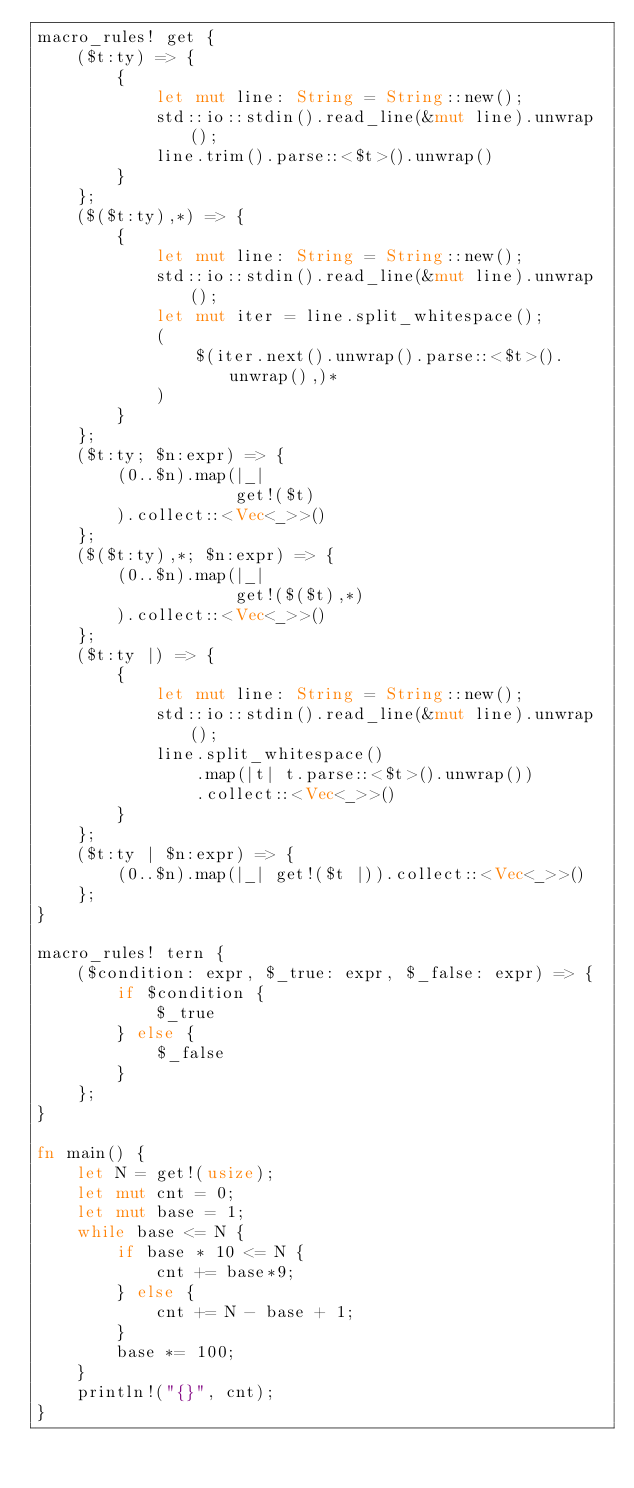<code> <loc_0><loc_0><loc_500><loc_500><_Rust_>macro_rules! get {
    ($t:ty) => {
        {
            let mut line: String = String::new();
            std::io::stdin().read_line(&mut line).unwrap();
            line.trim().parse::<$t>().unwrap()
        }
    };
    ($($t:ty),*) => {
        {
            let mut line: String = String::new();
            std::io::stdin().read_line(&mut line).unwrap();
            let mut iter = line.split_whitespace();
            (
                $(iter.next().unwrap().parse::<$t>().unwrap(),)*
            )
        }
    };
    ($t:ty; $n:expr) => {
        (0..$n).map(|_|
                    get!($t)
        ).collect::<Vec<_>>()
    };
    ($($t:ty),*; $n:expr) => {
        (0..$n).map(|_|
                    get!($($t),*)
        ).collect::<Vec<_>>()
    };
    ($t:ty |) => {
        {
            let mut line: String = String::new();
            std::io::stdin().read_line(&mut line).unwrap();
            line.split_whitespace()
                .map(|t| t.parse::<$t>().unwrap())
                .collect::<Vec<_>>()
        }
    };
    ($t:ty | $n:expr) => {
        (0..$n).map(|_| get!($t |)).collect::<Vec<_>>()
    };
}

macro_rules! tern {
    ($condition: expr, $_true: expr, $_false: expr) => {
        if $condition {
            $_true
        } else {
            $_false
        }
    };
}

fn main() {
    let N = get!(usize);
    let mut cnt = 0;
    let mut base = 1;
    while base <= N {
        if base * 10 <= N {
            cnt += base*9;
        } else {
            cnt += N - base + 1;
        }
        base *= 100;
    }
    println!("{}", cnt);
}
</code> 